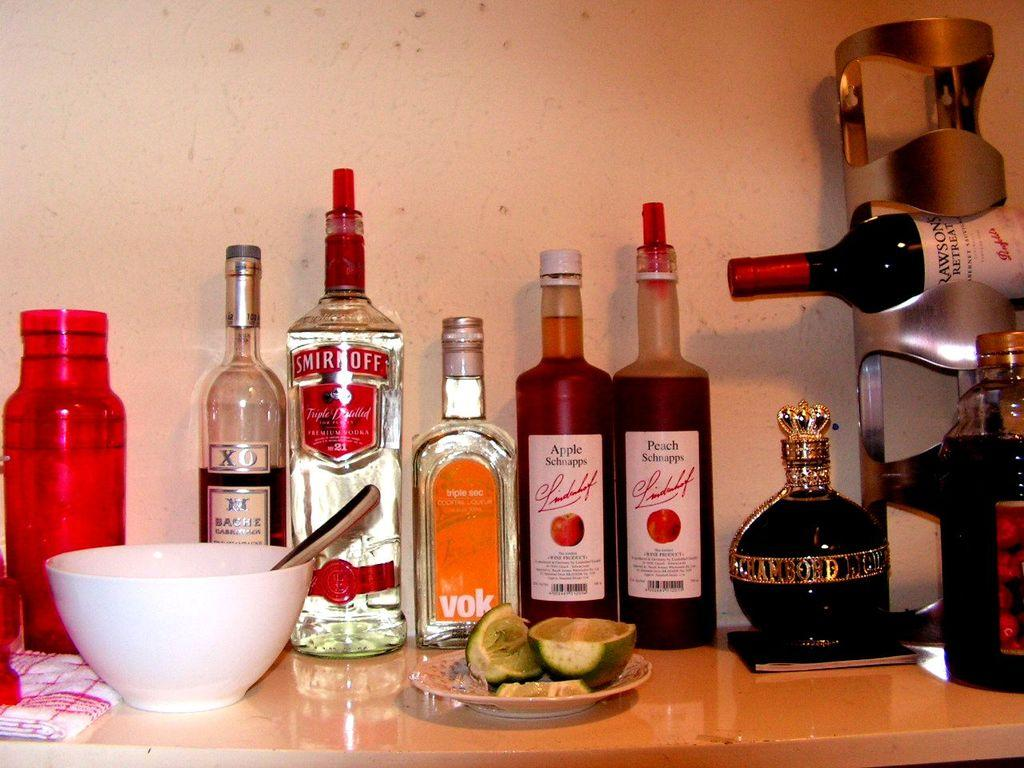<image>
Describe the image concisely. A Smirnoff premium vodka is on the table with some other alcohol. 